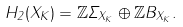<formula> <loc_0><loc_0><loc_500><loc_500>H _ { 2 } ( X _ { K } ) = \mathbb { Z } \Sigma _ { X _ { K } } \oplus \mathbb { Z } B _ { X _ { K } } .</formula> 